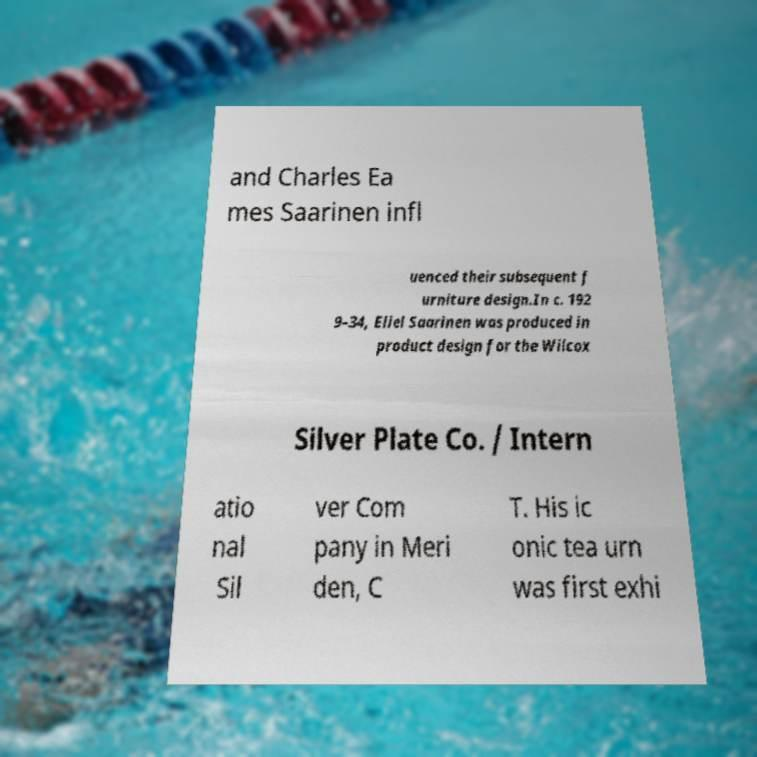Please read and relay the text visible in this image. What does it say? and Charles Ea mes Saarinen infl uenced their subsequent f urniture design.In c. 192 9–34, Eliel Saarinen was produced in product design for the Wilcox Silver Plate Co. / Intern atio nal Sil ver Com pany in Meri den, C T. His ic onic tea urn was first exhi 